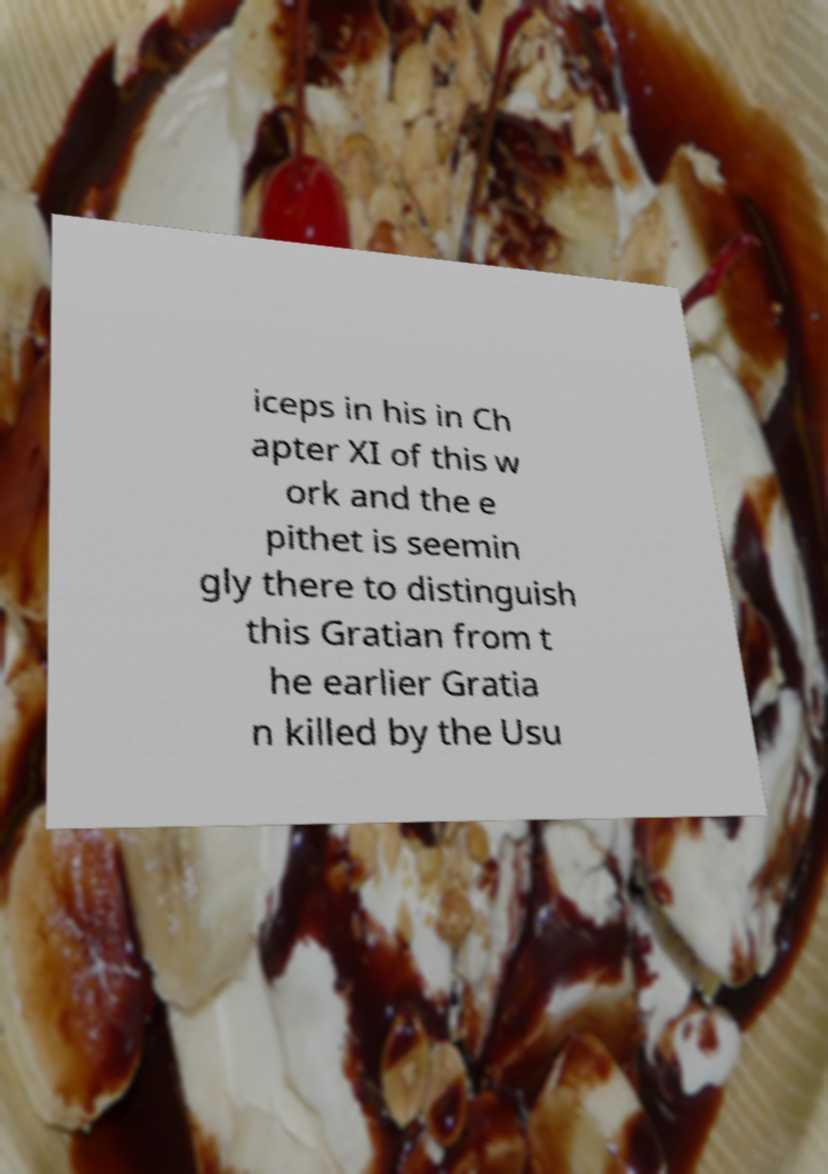Please read and relay the text visible in this image. What does it say? iceps in his in Ch apter XI of this w ork and the e pithet is seemin gly there to distinguish this Gratian from t he earlier Gratia n killed by the Usu 